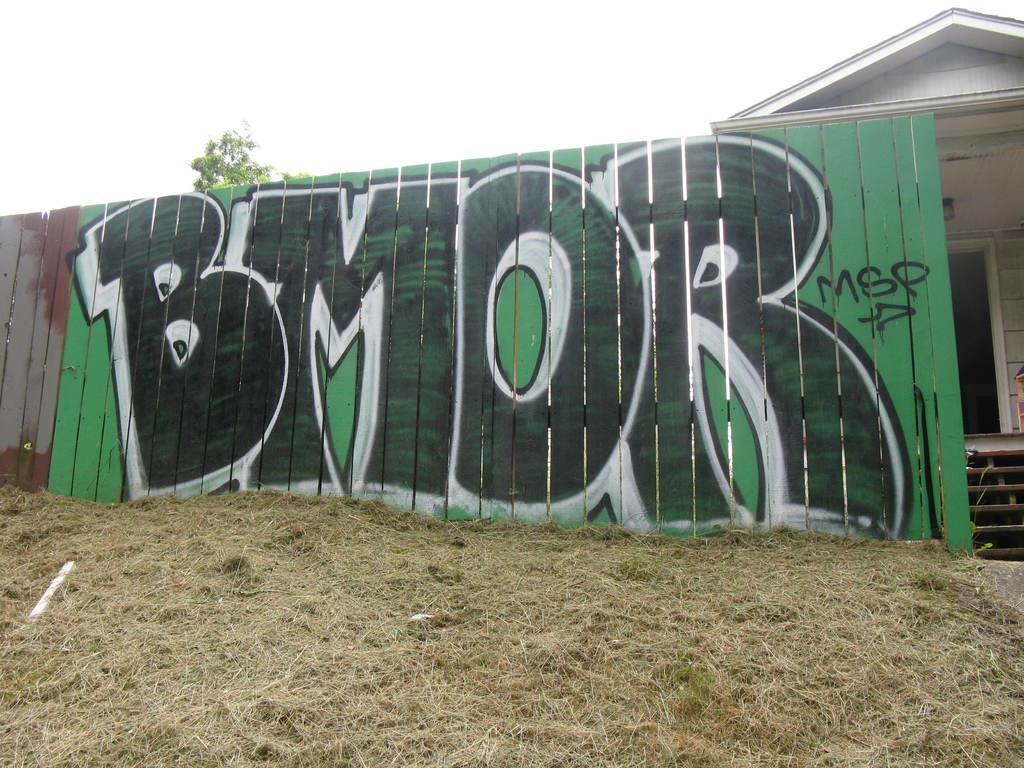Can you describe this image briefly? In the center of the image there is a painting on the wall. At the bottom of the image there is grass on the surface. In the background of the image there is a tree. There is a building and there is sky. 